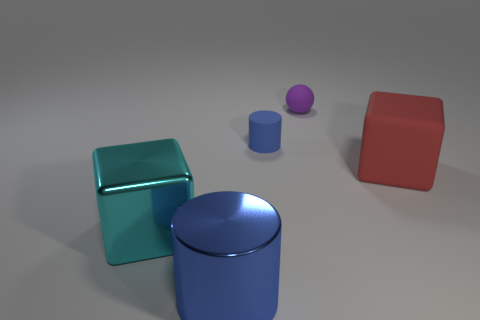Do the block that is behind the big shiny block and the large cube that is left of the large blue metallic thing have the same material?
Make the answer very short. No. Is the shape of the big object that is on the right side of the blue rubber thing the same as the cyan thing left of the big red object?
Your answer should be compact. Yes. Is the number of large cylinders that are in front of the blue metallic cylinder less than the number of tiny rubber balls?
Your response must be concise. Yes. What number of large metal objects are the same color as the tiny rubber cylinder?
Your answer should be very brief. 1. What is the size of the blue thing on the right side of the big blue object?
Offer a terse response. Small. What shape is the blue object on the left side of the blue thing that is behind the large thing left of the large cylinder?
Provide a short and direct response. Cylinder. The rubber thing that is both in front of the tiny purple thing and to the right of the small blue matte thing has what shape?
Your answer should be very brief. Cube. Are there any metallic cylinders that have the same size as the cyan shiny block?
Your answer should be compact. Yes. Do the small rubber object in front of the purple object and the big blue thing have the same shape?
Provide a short and direct response. Yes. Do the large blue metal object and the blue rubber object have the same shape?
Provide a short and direct response. Yes. 